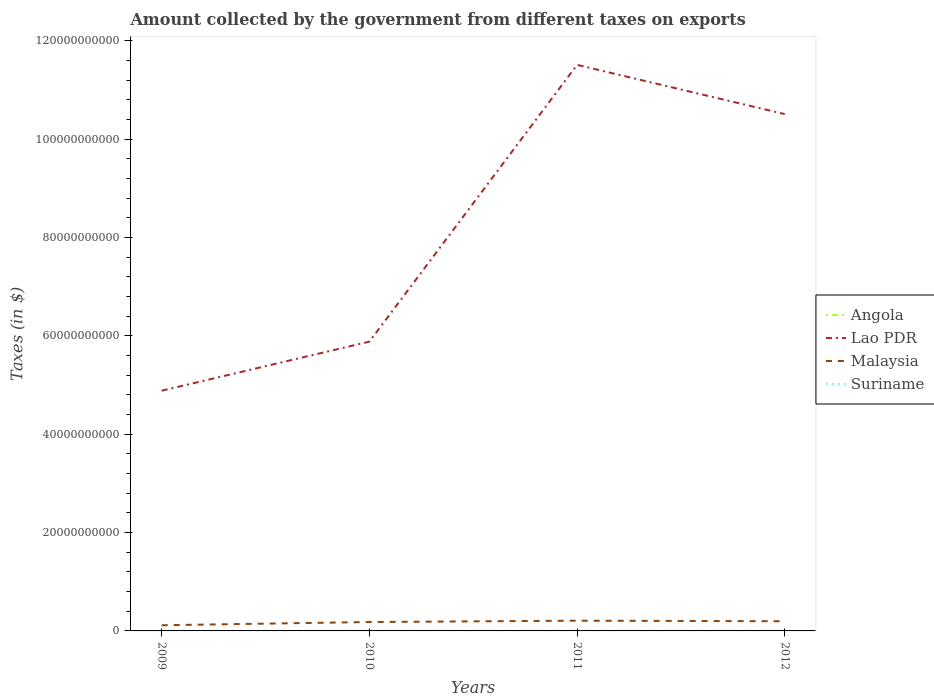How many different coloured lines are there?
Your answer should be compact. 4. Is the number of lines equal to the number of legend labels?
Give a very brief answer. Yes. Across all years, what is the maximum amount collected by the government from taxes on exports in Malaysia?
Your response must be concise. 1.15e+09. What is the total amount collected by the government from taxes on exports in Suriname in the graph?
Ensure brevity in your answer.  -5.66e+06. What is the difference between the highest and the second highest amount collected by the government from taxes on exports in Angola?
Provide a succinct answer. 1.07e+07. What is the difference between the highest and the lowest amount collected by the government from taxes on exports in Angola?
Ensure brevity in your answer.  2. How many lines are there?
Your response must be concise. 4. How many years are there in the graph?
Your answer should be very brief. 4. Are the values on the major ticks of Y-axis written in scientific E-notation?
Your response must be concise. No. Where does the legend appear in the graph?
Offer a terse response. Center right. How are the legend labels stacked?
Offer a very short reply. Vertical. What is the title of the graph?
Keep it short and to the point. Amount collected by the government from different taxes on exports. What is the label or title of the X-axis?
Your answer should be compact. Years. What is the label or title of the Y-axis?
Give a very brief answer. Taxes (in $). What is the Taxes (in $) in Angola in 2009?
Give a very brief answer. 7.26e+06. What is the Taxes (in $) of Lao PDR in 2009?
Keep it short and to the point. 4.88e+1. What is the Taxes (in $) in Malaysia in 2009?
Your answer should be compact. 1.15e+09. What is the Taxes (in $) of Suriname in 2009?
Provide a short and direct response. 4.27e+06. What is the Taxes (in $) in Angola in 2010?
Ensure brevity in your answer.  1.07e+07. What is the Taxes (in $) in Lao PDR in 2010?
Your answer should be compact. 5.88e+1. What is the Taxes (in $) of Malaysia in 2010?
Offer a terse response. 1.81e+09. What is the Taxes (in $) in Suriname in 2010?
Ensure brevity in your answer.  7.16e+06. What is the Taxes (in $) of Angola in 2011?
Your response must be concise. 1.11e+07. What is the Taxes (in $) of Lao PDR in 2011?
Keep it short and to the point. 1.15e+11. What is the Taxes (in $) of Malaysia in 2011?
Give a very brief answer. 2.08e+09. What is the Taxes (in $) of Suriname in 2011?
Make the answer very short. 9.93e+06. What is the Taxes (in $) of Angola in 2012?
Provide a succinct answer. 4.42e+05. What is the Taxes (in $) of Lao PDR in 2012?
Your response must be concise. 1.05e+11. What is the Taxes (in $) of Malaysia in 2012?
Ensure brevity in your answer.  1.97e+09. What is the Taxes (in $) in Suriname in 2012?
Ensure brevity in your answer.  9.10e+06. Across all years, what is the maximum Taxes (in $) of Angola?
Your answer should be compact. 1.11e+07. Across all years, what is the maximum Taxes (in $) of Lao PDR?
Your answer should be very brief. 1.15e+11. Across all years, what is the maximum Taxes (in $) of Malaysia?
Your answer should be very brief. 2.08e+09. Across all years, what is the maximum Taxes (in $) in Suriname?
Your response must be concise. 9.93e+06. Across all years, what is the minimum Taxes (in $) in Angola?
Offer a very short reply. 4.42e+05. Across all years, what is the minimum Taxes (in $) of Lao PDR?
Offer a very short reply. 4.88e+1. Across all years, what is the minimum Taxes (in $) of Malaysia?
Offer a terse response. 1.15e+09. Across all years, what is the minimum Taxes (in $) of Suriname?
Keep it short and to the point. 4.27e+06. What is the total Taxes (in $) in Angola in the graph?
Make the answer very short. 2.95e+07. What is the total Taxes (in $) of Lao PDR in the graph?
Make the answer very short. 3.28e+11. What is the total Taxes (in $) in Malaysia in the graph?
Your response must be concise. 7.01e+09. What is the total Taxes (in $) of Suriname in the graph?
Your answer should be compact. 3.05e+07. What is the difference between the Taxes (in $) of Angola in 2009 and that in 2010?
Ensure brevity in your answer.  -3.46e+06. What is the difference between the Taxes (in $) in Lao PDR in 2009 and that in 2010?
Provide a succinct answer. -9.98e+09. What is the difference between the Taxes (in $) of Malaysia in 2009 and that in 2010?
Your answer should be compact. -6.58e+08. What is the difference between the Taxes (in $) of Suriname in 2009 and that in 2010?
Offer a terse response. -2.89e+06. What is the difference between the Taxes (in $) of Angola in 2009 and that in 2011?
Provide a short and direct response. -3.86e+06. What is the difference between the Taxes (in $) in Lao PDR in 2009 and that in 2011?
Your response must be concise. -6.62e+1. What is the difference between the Taxes (in $) in Malaysia in 2009 and that in 2011?
Offer a very short reply. -9.29e+08. What is the difference between the Taxes (in $) of Suriname in 2009 and that in 2011?
Your answer should be very brief. -5.66e+06. What is the difference between the Taxes (in $) of Angola in 2009 and that in 2012?
Ensure brevity in your answer.  6.82e+06. What is the difference between the Taxes (in $) in Lao PDR in 2009 and that in 2012?
Make the answer very short. -5.62e+1. What is the difference between the Taxes (in $) of Malaysia in 2009 and that in 2012?
Your answer should be very brief. -8.16e+08. What is the difference between the Taxes (in $) of Suriname in 2009 and that in 2012?
Offer a very short reply. -4.83e+06. What is the difference between the Taxes (in $) in Angola in 2010 and that in 2011?
Provide a succinct answer. -4.03e+05. What is the difference between the Taxes (in $) of Lao PDR in 2010 and that in 2011?
Give a very brief answer. -5.63e+1. What is the difference between the Taxes (in $) of Malaysia in 2010 and that in 2011?
Your answer should be compact. -2.71e+08. What is the difference between the Taxes (in $) of Suriname in 2010 and that in 2011?
Your answer should be very brief. -2.77e+06. What is the difference between the Taxes (in $) in Angola in 2010 and that in 2012?
Provide a succinct answer. 1.03e+07. What is the difference between the Taxes (in $) of Lao PDR in 2010 and that in 2012?
Offer a terse response. -4.63e+1. What is the difference between the Taxes (in $) in Malaysia in 2010 and that in 2012?
Provide a short and direct response. -1.58e+08. What is the difference between the Taxes (in $) in Suriname in 2010 and that in 2012?
Provide a short and direct response. -1.94e+06. What is the difference between the Taxes (in $) of Angola in 2011 and that in 2012?
Your response must be concise. 1.07e+07. What is the difference between the Taxes (in $) in Lao PDR in 2011 and that in 2012?
Ensure brevity in your answer.  1.00e+1. What is the difference between the Taxes (in $) in Malaysia in 2011 and that in 2012?
Your response must be concise. 1.13e+08. What is the difference between the Taxes (in $) in Suriname in 2011 and that in 2012?
Provide a succinct answer. 8.28e+05. What is the difference between the Taxes (in $) in Angola in 2009 and the Taxes (in $) in Lao PDR in 2010?
Your answer should be compact. -5.88e+1. What is the difference between the Taxes (in $) of Angola in 2009 and the Taxes (in $) of Malaysia in 2010?
Your response must be concise. -1.80e+09. What is the difference between the Taxes (in $) of Angola in 2009 and the Taxes (in $) of Suriname in 2010?
Your answer should be very brief. 9.85e+04. What is the difference between the Taxes (in $) of Lao PDR in 2009 and the Taxes (in $) of Malaysia in 2010?
Keep it short and to the point. 4.70e+1. What is the difference between the Taxes (in $) of Lao PDR in 2009 and the Taxes (in $) of Suriname in 2010?
Keep it short and to the point. 4.88e+1. What is the difference between the Taxes (in $) in Malaysia in 2009 and the Taxes (in $) in Suriname in 2010?
Your answer should be very brief. 1.14e+09. What is the difference between the Taxes (in $) of Angola in 2009 and the Taxes (in $) of Lao PDR in 2011?
Ensure brevity in your answer.  -1.15e+11. What is the difference between the Taxes (in $) in Angola in 2009 and the Taxes (in $) in Malaysia in 2011?
Provide a succinct answer. -2.07e+09. What is the difference between the Taxes (in $) in Angola in 2009 and the Taxes (in $) in Suriname in 2011?
Make the answer very short. -2.67e+06. What is the difference between the Taxes (in $) in Lao PDR in 2009 and the Taxes (in $) in Malaysia in 2011?
Give a very brief answer. 4.68e+1. What is the difference between the Taxes (in $) of Lao PDR in 2009 and the Taxes (in $) of Suriname in 2011?
Give a very brief answer. 4.88e+1. What is the difference between the Taxes (in $) in Malaysia in 2009 and the Taxes (in $) in Suriname in 2011?
Your answer should be very brief. 1.14e+09. What is the difference between the Taxes (in $) in Angola in 2009 and the Taxes (in $) in Lao PDR in 2012?
Your answer should be compact. -1.05e+11. What is the difference between the Taxes (in $) of Angola in 2009 and the Taxes (in $) of Malaysia in 2012?
Give a very brief answer. -1.96e+09. What is the difference between the Taxes (in $) of Angola in 2009 and the Taxes (in $) of Suriname in 2012?
Provide a short and direct response. -1.84e+06. What is the difference between the Taxes (in $) of Lao PDR in 2009 and the Taxes (in $) of Malaysia in 2012?
Give a very brief answer. 4.69e+1. What is the difference between the Taxes (in $) of Lao PDR in 2009 and the Taxes (in $) of Suriname in 2012?
Your answer should be very brief. 4.88e+1. What is the difference between the Taxes (in $) of Malaysia in 2009 and the Taxes (in $) of Suriname in 2012?
Your response must be concise. 1.14e+09. What is the difference between the Taxes (in $) in Angola in 2010 and the Taxes (in $) in Lao PDR in 2011?
Give a very brief answer. -1.15e+11. What is the difference between the Taxes (in $) of Angola in 2010 and the Taxes (in $) of Malaysia in 2011?
Give a very brief answer. -2.07e+09. What is the difference between the Taxes (in $) in Angola in 2010 and the Taxes (in $) in Suriname in 2011?
Provide a succinct answer. 7.85e+05. What is the difference between the Taxes (in $) of Lao PDR in 2010 and the Taxes (in $) of Malaysia in 2011?
Ensure brevity in your answer.  5.67e+1. What is the difference between the Taxes (in $) in Lao PDR in 2010 and the Taxes (in $) in Suriname in 2011?
Ensure brevity in your answer.  5.88e+1. What is the difference between the Taxes (in $) in Malaysia in 2010 and the Taxes (in $) in Suriname in 2011?
Give a very brief answer. 1.80e+09. What is the difference between the Taxes (in $) of Angola in 2010 and the Taxes (in $) of Lao PDR in 2012?
Your response must be concise. -1.05e+11. What is the difference between the Taxes (in $) of Angola in 2010 and the Taxes (in $) of Malaysia in 2012?
Ensure brevity in your answer.  -1.96e+09. What is the difference between the Taxes (in $) of Angola in 2010 and the Taxes (in $) of Suriname in 2012?
Your answer should be very brief. 1.61e+06. What is the difference between the Taxes (in $) of Lao PDR in 2010 and the Taxes (in $) of Malaysia in 2012?
Provide a succinct answer. 5.68e+1. What is the difference between the Taxes (in $) in Lao PDR in 2010 and the Taxes (in $) in Suriname in 2012?
Make the answer very short. 5.88e+1. What is the difference between the Taxes (in $) in Malaysia in 2010 and the Taxes (in $) in Suriname in 2012?
Ensure brevity in your answer.  1.80e+09. What is the difference between the Taxes (in $) in Angola in 2011 and the Taxes (in $) in Lao PDR in 2012?
Offer a terse response. -1.05e+11. What is the difference between the Taxes (in $) of Angola in 2011 and the Taxes (in $) of Malaysia in 2012?
Offer a terse response. -1.96e+09. What is the difference between the Taxes (in $) in Angola in 2011 and the Taxes (in $) in Suriname in 2012?
Your answer should be compact. 2.02e+06. What is the difference between the Taxes (in $) in Lao PDR in 2011 and the Taxes (in $) in Malaysia in 2012?
Your answer should be compact. 1.13e+11. What is the difference between the Taxes (in $) of Lao PDR in 2011 and the Taxes (in $) of Suriname in 2012?
Offer a very short reply. 1.15e+11. What is the difference between the Taxes (in $) in Malaysia in 2011 and the Taxes (in $) in Suriname in 2012?
Provide a short and direct response. 2.07e+09. What is the average Taxes (in $) in Angola per year?
Provide a short and direct response. 7.38e+06. What is the average Taxes (in $) of Lao PDR per year?
Ensure brevity in your answer.  8.20e+1. What is the average Taxes (in $) of Malaysia per year?
Make the answer very short. 1.75e+09. What is the average Taxes (in $) of Suriname per year?
Give a very brief answer. 7.62e+06. In the year 2009, what is the difference between the Taxes (in $) in Angola and Taxes (in $) in Lao PDR?
Your answer should be compact. -4.88e+1. In the year 2009, what is the difference between the Taxes (in $) of Angola and Taxes (in $) of Malaysia?
Your response must be concise. -1.14e+09. In the year 2009, what is the difference between the Taxes (in $) in Angola and Taxes (in $) in Suriname?
Your answer should be compact. 2.99e+06. In the year 2009, what is the difference between the Taxes (in $) in Lao PDR and Taxes (in $) in Malaysia?
Offer a terse response. 4.77e+1. In the year 2009, what is the difference between the Taxes (in $) in Lao PDR and Taxes (in $) in Suriname?
Your answer should be compact. 4.88e+1. In the year 2009, what is the difference between the Taxes (in $) in Malaysia and Taxes (in $) in Suriname?
Your answer should be very brief. 1.15e+09. In the year 2010, what is the difference between the Taxes (in $) of Angola and Taxes (in $) of Lao PDR?
Offer a terse response. -5.88e+1. In the year 2010, what is the difference between the Taxes (in $) in Angola and Taxes (in $) in Malaysia?
Give a very brief answer. -1.80e+09. In the year 2010, what is the difference between the Taxes (in $) in Angola and Taxes (in $) in Suriname?
Offer a terse response. 3.55e+06. In the year 2010, what is the difference between the Taxes (in $) of Lao PDR and Taxes (in $) of Malaysia?
Your answer should be compact. 5.70e+1. In the year 2010, what is the difference between the Taxes (in $) of Lao PDR and Taxes (in $) of Suriname?
Offer a terse response. 5.88e+1. In the year 2010, what is the difference between the Taxes (in $) of Malaysia and Taxes (in $) of Suriname?
Your response must be concise. 1.80e+09. In the year 2011, what is the difference between the Taxes (in $) in Angola and Taxes (in $) in Lao PDR?
Give a very brief answer. -1.15e+11. In the year 2011, what is the difference between the Taxes (in $) of Angola and Taxes (in $) of Malaysia?
Offer a very short reply. -2.07e+09. In the year 2011, what is the difference between the Taxes (in $) of Angola and Taxes (in $) of Suriname?
Provide a short and direct response. 1.19e+06. In the year 2011, what is the difference between the Taxes (in $) in Lao PDR and Taxes (in $) in Malaysia?
Make the answer very short. 1.13e+11. In the year 2011, what is the difference between the Taxes (in $) of Lao PDR and Taxes (in $) of Suriname?
Provide a short and direct response. 1.15e+11. In the year 2011, what is the difference between the Taxes (in $) of Malaysia and Taxes (in $) of Suriname?
Give a very brief answer. 2.07e+09. In the year 2012, what is the difference between the Taxes (in $) of Angola and Taxes (in $) of Lao PDR?
Offer a very short reply. -1.05e+11. In the year 2012, what is the difference between the Taxes (in $) of Angola and Taxes (in $) of Malaysia?
Ensure brevity in your answer.  -1.97e+09. In the year 2012, what is the difference between the Taxes (in $) of Angola and Taxes (in $) of Suriname?
Provide a short and direct response. -8.66e+06. In the year 2012, what is the difference between the Taxes (in $) of Lao PDR and Taxes (in $) of Malaysia?
Your answer should be compact. 1.03e+11. In the year 2012, what is the difference between the Taxes (in $) of Lao PDR and Taxes (in $) of Suriname?
Ensure brevity in your answer.  1.05e+11. In the year 2012, what is the difference between the Taxes (in $) in Malaysia and Taxes (in $) in Suriname?
Your response must be concise. 1.96e+09. What is the ratio of the Taxes (in $) of Angola in 2009 to that in 2010?
Your response must be concise. 0.68. What is the ratio of the Taxes (in $) of Lao PDR in 2009 to that in 2010?
Your answer should be very brief. 0.83. What is the ratio of the Taxes (in $) in Malaysia in 2009 to that in 2010?
Offer a very short reply. 0.64. What is the ratio of the Taxes (in $) in Suriname in 2009 to that in 2010?
Ensure brevity in your answer.  0.6. What is the ratio of the Taxes (in $) in Angola in 2009 to that in 2011?
Your response must be concise. 0.65. What is the ratio of the Taxes (in $) in Lao PDR in 2009 to that in 2011?
Make the answer very short. 0.42. What is the ratio of the Taxes (in $) of Malaysia in 2009 to that in 2011?
Your answer should be very brief. 0.55. What is the ratio of the Taxes (in $) of Suriname in 2009 to that in 2011?
Ensure brevity in your answer.  0.43. What is the ratio of the Taxes (in $) in Angola in 2009 to that in 2012?
Your answer should be very brief. 16.42. What is the ratio of the Taxes (in $) of Lao PDR in 2009 to that in 2012?
Offer a very short reply. 0.46. What is the ratio of the Taxes (in $) in Malaysia in 2009 to that in 2012?
Your answer should be compact. 0.59. What is the ratio of the Taxes (in $) in Suriname in 2009 to that in 2012?
Make the answer very short. 0.47. What is the ratio of the Taxes (in $) of Angola in 2010 to that in 2011?
Make the answer very short. 0.96. What is the ratio of the Taxes (in $) of Lao PDR in 2010 to that in 2011?
Make the answer very short. 0.51. What is the ratio of the Taxes (in $) in Malaysia in 2010 to that in 2011?
Give a very brief answer. 0.87. What is the ratio of the Taxes (in $) in Suriname in 2010 to that in 2011?
Make the answer very short. 0.72. What is the ratio of the Taxes (in $) of Angola in 2010 to that in 2012?
Your answer should be very brief. 24.23. What is the ratio of the Taxes (in $) in Lao PDR in 2010 to that in 2012?
Your response must be concise. 0.56. What is the ratio of the Taxes (in $) in Malaysia in 2010 to that in 2012?
Keep it short and to the point. 0.92. What is the ratio of the Taxes (in $) of Suriname in 2010 to that in 2012?
Provide a succinct answer. 0.79. What is the ratio of the Taxes (in $) in Angola in 2011 to that in 2012?
Ensure brevity in your answer.  25.14. What is the ratio of the Taxes (in $) in Lao PDR in 2011 to that in 2012?
Provide a short and direct response. 1.1. What is the ratio of the Taxes (in $) of Malaysia in 2011 to that in 2012?
Provide a short and direct response. 1.06. What is the ratio of the Taxes (in $) in Suriname in 2011 to that in 2012?
Give a very brief answer. 1.09. What is the difference between the highest and the second highest Taxes (in $) in Angola?
Your response must be concise. 4.03e+05. What is the difference between the highest and the second highest Taxes (in $) in Lao PDR?
Give a very brief answer. 1.00e+1. What is the difference between the highest and the second highest Taxes (in $) of Malaysia?
Keep it short and to the point. 1.13e+08. What is the difference between the highest and the second highest Taxes (in $) of Suriname?
Offer a terse response. 8.28e+05. What is the difference between the highest and the lowest Taxes (in $) in Angola?
Ensure brevity in your answer.  1.07e+07. What is the difference between the highest and the lowest Taxes (in $) of Lao PDR?
Ensure brevity in your answer.  6.62e+1. What is the difference between the highest and the lowest Taxes (in $) in Malaysia?
Offer a terse response. 9.29e+08. What is the difference between the highest and the lowest Taxes (in $) in Suriname?
Provide a short and direct response. 5.66e+06. 